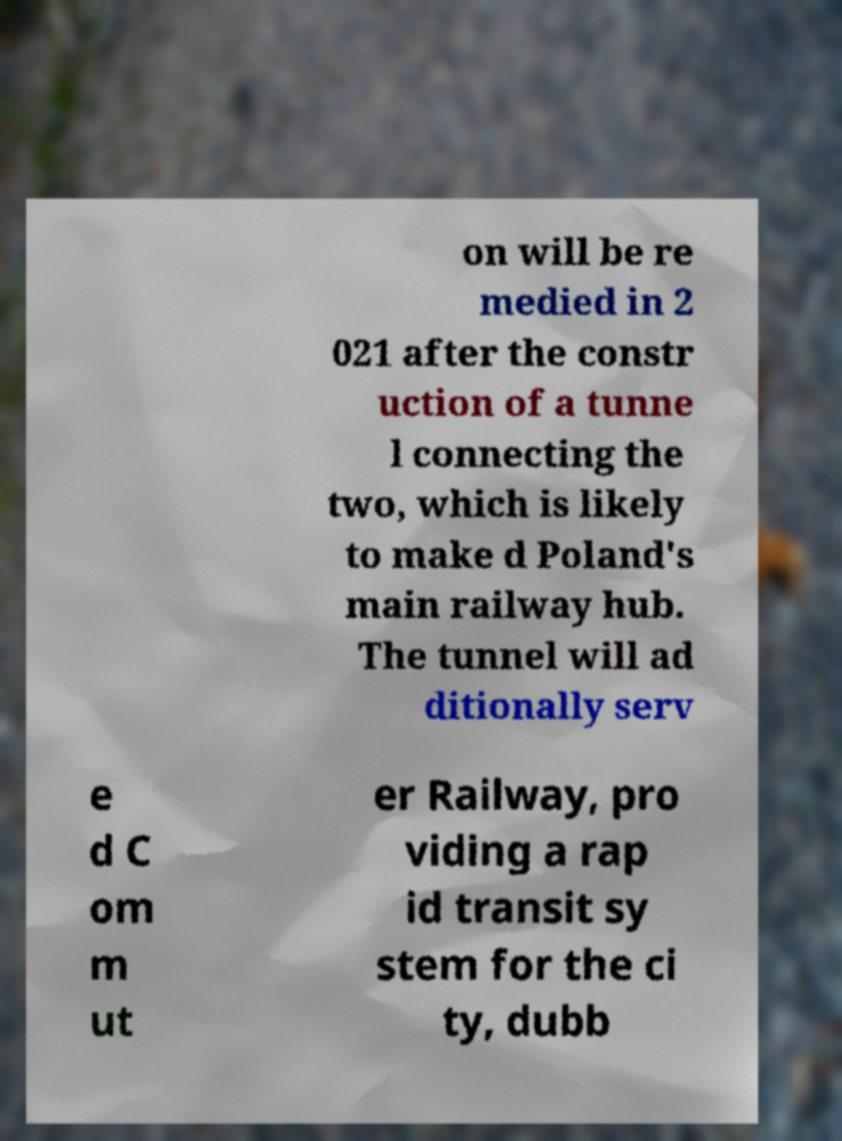What messages or text are displayed in this image? I need them in a readable, typed format. on will be re medied in 2 021 after the constr uction of a tunne l connecting the two, which is likely to make d Poland's main railway hub. The tunnel will ad ditionally serv e d C om m ut er Railway, pro viding a rap id transit sy stem for the ci ty, dubb 